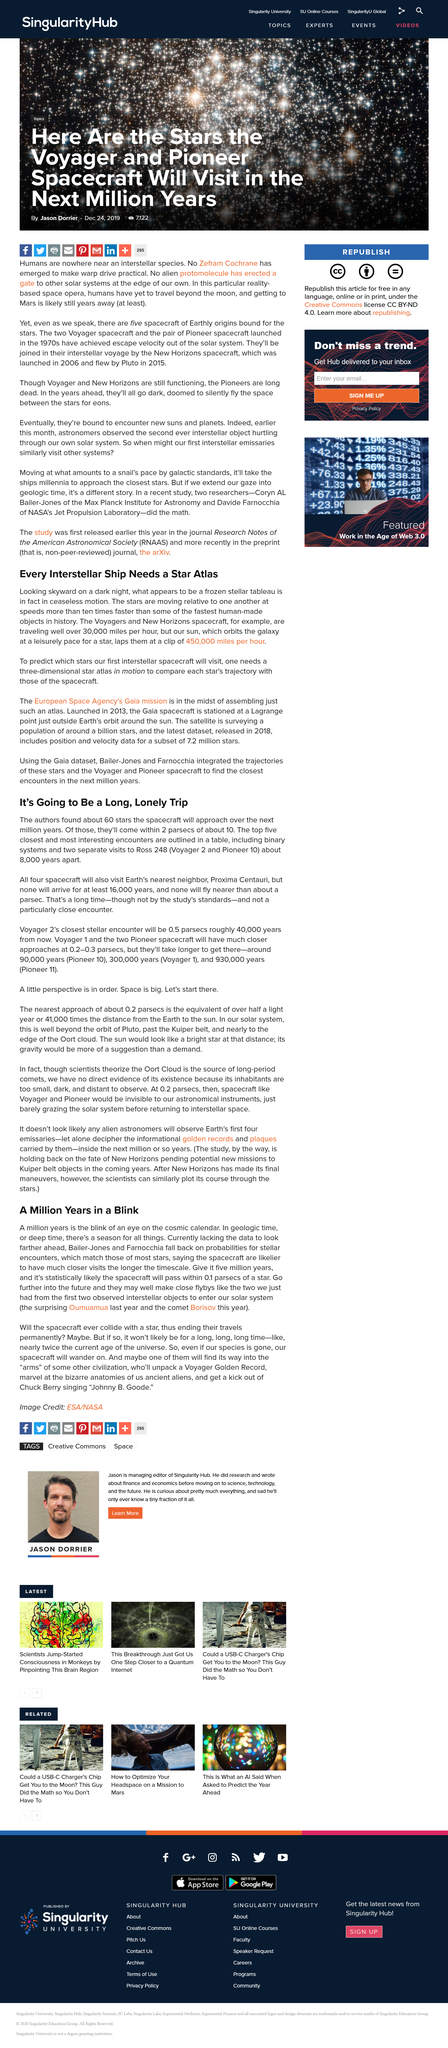Indicate a few pertinent items in this graphic. The Voyagers and New Horizons spacecraft are travelling at an extremely fast speed, exceeding 30,000 miles per hour. Earth's nearest neighbor is Proxima Centauri. The first two interstellar objects to enter our solar system were Oumuamua and comet Borisov, which were observed upon their arrival. The Sun orbits the galaxy at a speed of 450,000 miles per hour. To determine which stars our first interstellar spacecraft will visit, we need a three-dimensional star atlas that is in motion. This will enable us to predict which stars the spacecraft will visit as it travels through the vast expanse of space. 